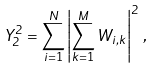Convert formula to latex. <formula><loc_0><loc_0><loc_500><loc_500>Y _ { 2 } ^ { 2 } = \sum _ { i = 1 } ^ { N } \left | \sum _ { k = 1 } ^ { M } W _ { i , k } \right | ^ { 2 } \, ,</formula> 